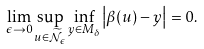Convert formula to latex. <formula><loc_0><loc_0><loc_500><loc_500>\lim _ { \epsilon \rightarrow 0 } \sup _ { u \in \widetilde { \mathcal { N } } _ { \epsilon } } \inf _ { y \in M _ { \delta } } \left | \beta ( u ) - y \right | = 0 .</formula> 